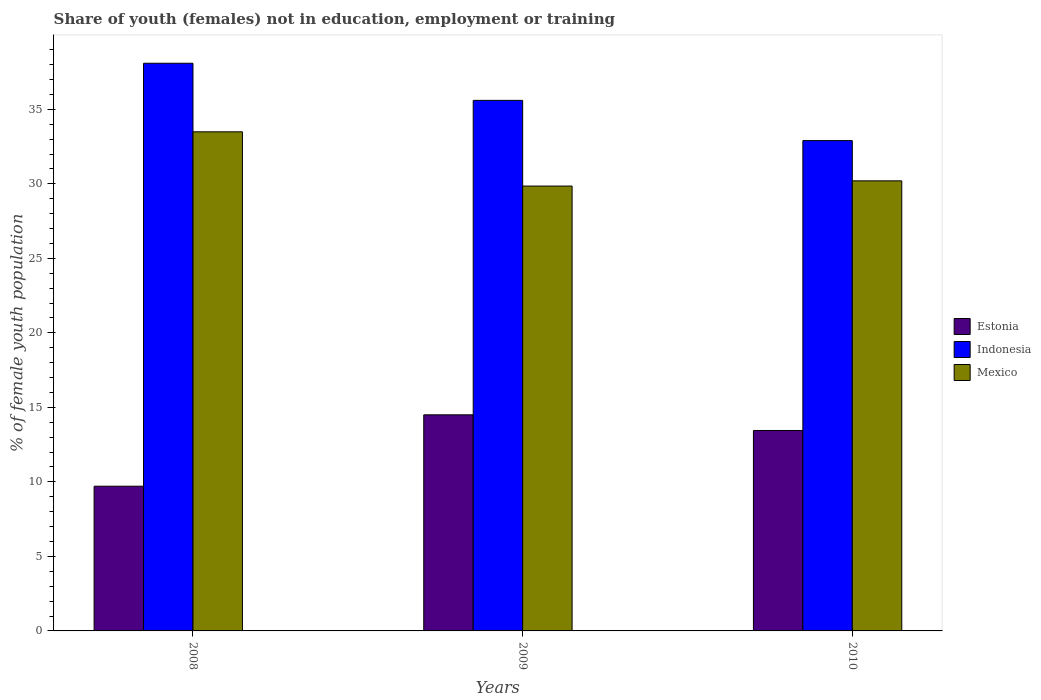How many groups of bars are there?
Give a very brief answer. 3. Are the number of bars per tick equal to the number of legend labels?
Provide a succinct answer. Yes. How many bars are there on the 2nd tick from the right?
Provide a succinct answer. 3. What is the label of the 3rd group of bars from the left?
Offer a very short reply. 2010. What is the percentage of unemployed female population in in Mexico in 2009?
Ensure brevity in your answer.  29.85. Across all years, what is the maximum percentage of unemployed female population in in Estonia?
Provide a succinct answer. 14.5. Across all years, what is the minimum percentage of unemployed female population in in Estonia?
Provide a short and direct response. 9.71. In which year was the percentage of unemployed female population in in Mexico minimum?
Ensure brevity in your answer.  2009. What is the total percentage of unemployed female population in in Indonesia in the graph?
Provide a short and direct response. 106.59. What is the difference between the percentage of unemployed female population in in Indonesia in 2009 and that in 2010?
Offer a very short reply. 2.7. What is the difference between the percentage of unemployed female population in in Mexico in 2010 and the percentage of unemployed female population in in Estonia in 2009?
Your answer should be very brief. 15.7. What is the average percentage of unemployed female population in in Estonia per year?
Offer a very short reply. 12.55. In the year 2010, what is the difference between the percentage of unemployed female population in in Mexico and percentage of unemployed female population in in Estonia?
Keep it short and to the point. 16.75. What is the ratio of the percentage of unemployed female population in in Estonia in 2008 to that in 2009?
Ensure brevity in your answer.  0.67. What is the difference between the highest and the second highest percentage of unemployed female population in in Mexico?
Keep it short and to the point. 3.29. What is the difference between the highest and the lowest percentage of unemployed female population in in Estonia?
Offer a terse response. 4.79. In how many years, is the percentage of unemployed female population in in Indonesia greater than the average percentage of unemployed female population in in Indonesia taken over all years?
Your response must be concise. 2. Is the sum of the percentage of unemployed female population in in Indonesia in 2008 and 2010 greater than the maximum percentage of unemployed female population in in Mexico across all years?
Provide a succinct answer. Yes. What does the 1st bar from the left in 2008 represents?
Offer a terse response. Estonia. What does the 3rd bar from the right in 2009 represents?
Make the answer very short. Estonia. Is it the case that in every year, the sum of the percentage of unemployed female population in in Mexico and percentage of unemployed female population in in Indonesia is greater than the percentage of unemployed female population in in Estonia?
Keep it short and to the point. Yes. How many bars are there?
Ensure brevity in your answer.  9. Are all the bars in the graph horizontal?
Your answer should be very brief. No. How many years are there in the graph?
Your answer should be compact. 3. Where does the legend appear in the graph?
Ensure brevity in your answer.  Center right. How many legend labels are there?
Ensure brevity in your answer.  3. What is the title of the graph?
Make the answer very short. Share of youth (females) not in education, employment or training. Does "Sint Maarten (Dutch part)" appear as one of the legend labels in the graph?
Your answer should be compact. No. What is the label or title of the X-axis?
Provide a succinct answer. Years. What is the label or title of the Y-axis?
Ensure brevity in your answer.  % of female youth population. What is the % of female youth population of Estonia in 2008?
Keep it short and to the point. 9.71. What is the % of female youth population of Indonesia in 2008?
Provide a succinct answer. 38.09. What is the % of female youth population in Mexico in 2008?
Keep it short and to the point. 33.49. What is the % of female youth population of Indonesia in 2009?
Ensure brevity in your answer.  35.6. What is the % of female youth population of Mexico in 2009?
Provide a short and direct response. 29.85. What is the % of female youth population of Estonia in 2010?
Offer a terse response. 13.45. What is the % of female youth population of Indonesia in 2010?
Keep it short and to the point. 32.9. What is the % of female youth population in Mexico in 2010?
Provide a succinct answer. 30.2. Across all years, what is the maximum % of female youth population in Indonesia?
Your answer should be compact. 38.09. Across all years, what is the maximum % of female youth population in Mexico?
Give a very brief answer. 33.49. Across all years, what is the minimum % of female youth population in Estonia?
Give a very brief answer. 9.71. Across all years, what is the minimum % of female youth population of Indonesia?
Your answer should be compact. 32.9. Across all years, what is the minimum % of female youth population in Mexico?
Your response must be concise. 29.85. What is the total % of female youth population in Estonia in the graph?
Give a very brief answer. 37.66. What is the total % of female youth population of Indonesia in the graph?
Make the answer very short. 106.59. What is the total % of female youth population of Mexico in the graph?
Make the answer very short. 93.54. What is the difference between the % of female youth population of Estonia in 2008 and that in 2009?
Ensure brevity in your answer.  -4.79. What is the difference between the % of female youth population of Indonesia in 2008 and that in 2009?
Give a very brief answer. 2.49. What is the difference between the % of female youth population of Mexico in 2008 and that in 2009?
Give a very brief answer. 3.64. What is the difference between the % of female youth population in Estonia in 2008 and that in 2010?
Your answer should be compact. -3.74. What is the difference between the % of female youth population of Indonesia in 2008 and that in 2010?
Your answer should be compact. 5.19. What is the difference between the % of female youth population of Mexico in 2008 and that in 2010?
Offer a terse response. 3.29. What is the difference between the % of female youth population of Mexico in 2009 and that in 2010?
Keep it short and to the point. -0.35. What is the difference between the % of female youth population in Estonia in 2008 and the % of female youth population in Indonesia in 2009?
Make the answer very short. -25.89. What is the difference between the % of female youth population in Estonia in 2008 and the % of female youth population in Mexico in 2009?
Your answer should be very brief. -20.14. What is the difference between the % of female youth population in Indonesia in 2008 and the % of female youth population in Mexico in 2009?
Your answer should be compact. 8.24. What is the difference between the % of female youth population of Estonia in 2008 and the % of female youth population of Indonesia in 2010?
Make the answer very short. -23.19. What is the difference between the % of female youth population in Estonia in 2008 and the % of female youth population in Mexico in 2010?
Provide a short and direct response. -20.49. What is the difference between the % of female youth population in Indonesia in 2008 and the % of female youth population in Mexico in 2010?
Offer a terse response. 7.89. What is the difference between the % of female youth population of Estonia in 2009 and the % of female youth population of Indonesia in 2010?
Keep it short and to the point. -18.4. What is the difference between the % of female youth population of Estonia in 2009 and the % of female youth population of Mexico in 2010?
Provide a succinct answer. -15.7. What is the difference between the % of female youth population of Indonesia in 2009 and the % of female youth population of Mexico in 2010?
Provide a succinct answer. 5.4. What is the average % of female youth population of Estonia per year?
Keep it short and to the point. 12.55. What is the average % of female youth population in Indonesia per year?
Give a very brief answer. 35.53. What is the average % of female youth population of Mexico per year?
Ensure brevity in your answer.  31.18. In the year 2008, what is the difference between the % of female youth population in Estonia and % of female youth population in Indonesia?
Your answer should be compact. -28.38. In the year 2008, what is the difference between the % of female youth population of Estonia and % of female youth population of Mexico?
Ensure brevity in your answer.  -23.78. In the year 2009, what is the difference between the % of female youth population in Estonia and % of female youth population in Indonesia?
Your answer should be compact. -21.1. In the year 2009, what is the difference between the % of female youth population in Estonia and % of female youth population in Mexico?
Your answer should be compact. -15.35. In the year 2009, what is the difference between the % of female youth population in Indonesia and % of female youth population in Mexico?
Your response must be concise. 5.75. In the year 2010, what is the difference between the % of female youth population of Estonia and % of female youth population of Indonesia?
Ensure brevity in your answer.  -19.45. In the year 2010, what is the difference between the % of female youth population in Estonia and % of female youth population in Mexico?
Provide a succinct answer. -16.75. What is the ratio of the % of female youth population in Estonia in 2008 to that in 2009?
Your answer should be compact. 0.67. What is the ratio of the % of female youth population of Indonesia in 2008 to that in 2009?
Your response must be concise. 1.07. What is the ratio of the % of female youth population of Mexico in 2008 to that in 2009?
Offer a very short reply. 1.12. What is the ratio of the % of female youth population in Estonia in 2008 to that in 2010?
Make the answer very short. 0.72. What is the ratio of the % of female youth population in Indonesia in 2008 to that in 2010?
Make the answer very short. 1.16. What is the ratio of the % of female youth population of Mexico in 2008 to that in 2010?
Provide a succinct answer. 1.11. What is the ratio of the % of female youth population of Estonia in 2009 to that in 2010?
Your answer should be compact. 1.08. What is the ratio of the % of female youth population in Indonesia in 2009 to that in 2010?
Your answer should be compact. 1.08. What is the ratio of the % of female youth population in Mexico in 2009 to that in 2010?
Ensure brevity in your answer.  0.99. What is the difference between the highest and the second highest % of female youth population in Indonesia?
Your answer should be very brief. 2.49. What is the difference between the highest and the second highest % of female youth population of Mexico?
Keep it short and to the point. 3.29. What is the difference between the highest and the lowest % of female youth population in Estonia?
Make the answer very short. 4.79. What is the difference between the highest and the lowest % of female youth population in Indonesia?
Make the answer very short. 5.19. What is the difference between the highest and the lowest % of female youth population of Mexico?
Make the answer very short. 3.64. 